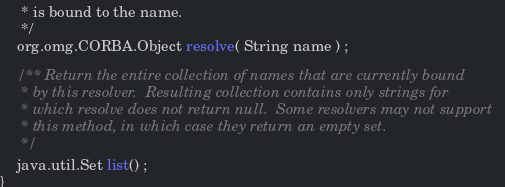<code> <loc_0><loc_0><loc_500><loc_500><_Java_>     * is bound to the name.
     */
    org.omg.CORBA.Object resolve( String name ) ;

    /** Return the entire collection of names that are currently bound
     * by this resolver.  Resulting collection contains only strings for
     * which resolve does not return null.  Some resolvers may not support
     * this method, in which case they return an empty set.
     */
    java.util.Set list() ;
}
</code> 